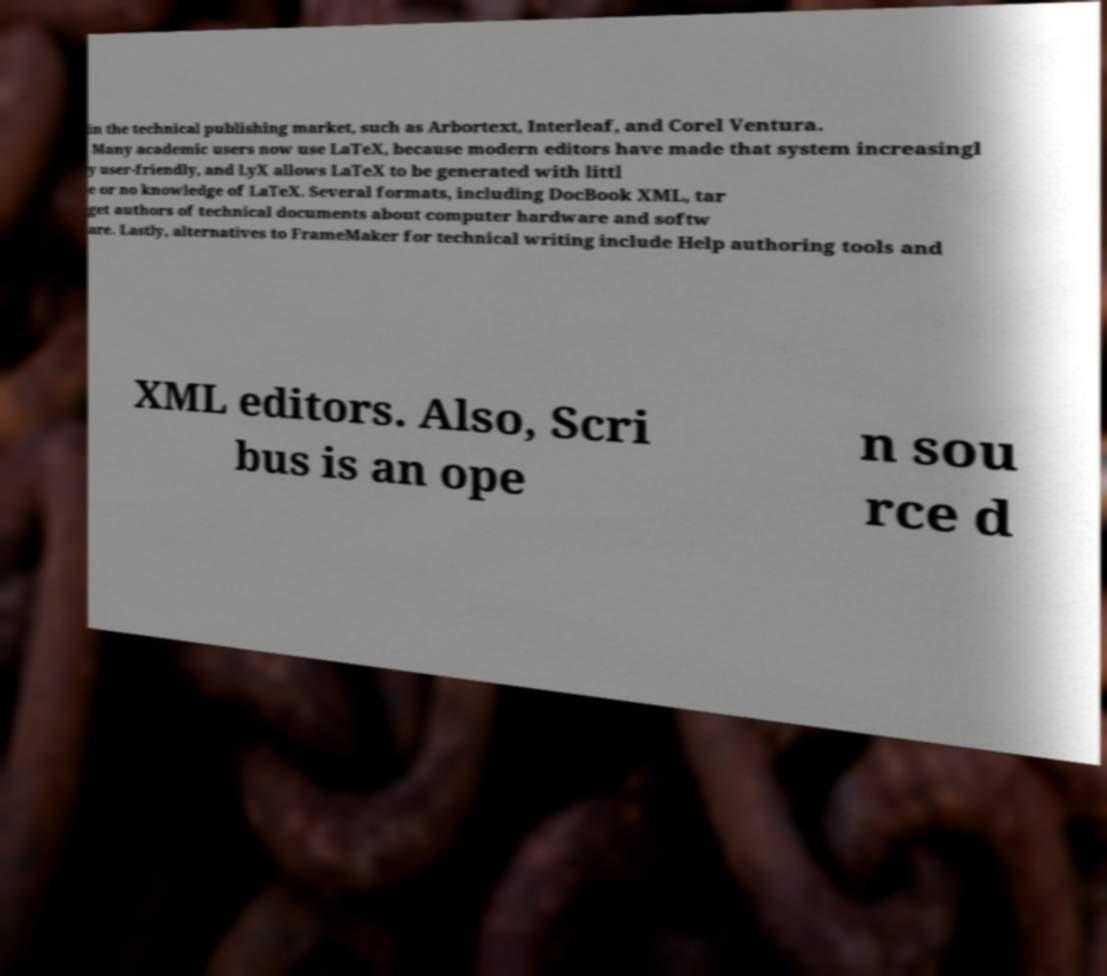Could you extract and type out the text from this image? in the technical publishing market, such as Arbortext, Interleaf, and Corel Ventura. Many academic users now use LaTeX, because modern editors have made that system increasingl y user-friendly, and LyX allows LaTeX to be generated with littl e or no knowledge of LaTeX. Several formats, including DocBook XML, tar get authors of technical documents about computer hardware and softw are. Lastly, alternatives to FrameMaker for technical writing include Help authoring tools and XML editors. Also, Scri bus is an ope n sou rce d 